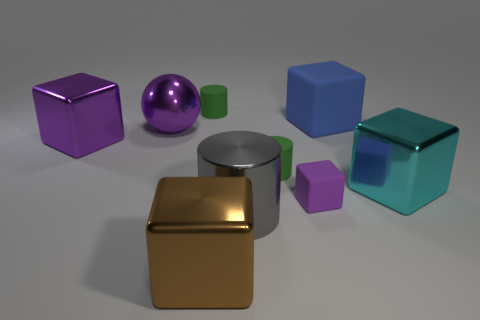Subtract all cyan blocks. How many blocks are left? 4 Subtract all tiny purple cubes. How many cubes are left? 4 Subtract all brown blocks. Subtract all brown cylinders. How many blocks are left? 4 Add 1 big gray shiny cylinders. How many objects exist? 10 Subtract 0 yellow cubes. How many objects are left? 9 Subtract all cylinders. How many objects are left? 6 Subtract all tiny blue shiny objects. Subtract all purple shiny spheres. How many objects are left? 8 Add 9 gray metal objects. How many gray metal objects are left? 10 Add 4 big green balls. How many big green balls exist? 4 